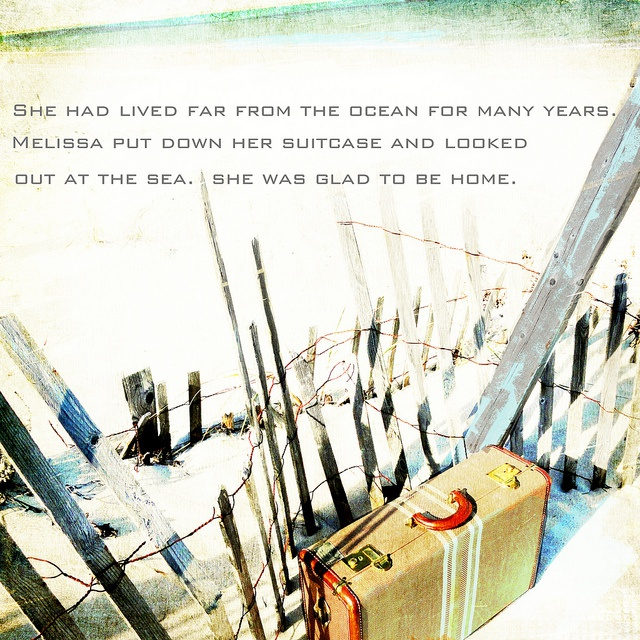Describe the objects in this image and their specific colors. I can see a suitcase in beige, khaki, and tan tones in this image. 